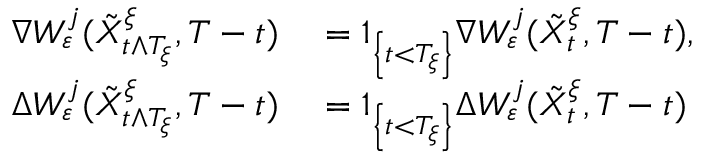Convert formula to latex. <formula><loc_0><loc_0><loc_500><loc_500>\begin{array} { r l } { \nabla W _ { \varepsilon } ^ { j } ( \tilde { X } _ { t \wedge T _ { \xi } } ^ { \xi } , T - t ) } & = 1 _ { \left \{ t < T _ { \xi } \right \} } \nabla W _ { \varepsilon } ^ { j } ( \tilde { X } _ { t } ^ { \xi } , T - t ) , } \\ { \Delta W _ { \varepsilon } ^ { j } ( \tilde { X } _ { t \wedge T _ { \xi } } ^ { \xi } , T - t ) } & = 1 _ { \left \{ t < T _ { \xi } \right \} } \Delta W _ { \varepsilon } ^ { j } ( \tilde { X } _ { t } ^ { \xi } , T - t ) } \end{array}</formula> 